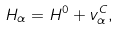<formula> <loc_0><loc_0><loc_500><loc_500>H _ { \alpha } = H ^ { 0 } + v _ { \alpha } ^ { C } ,</formula> 